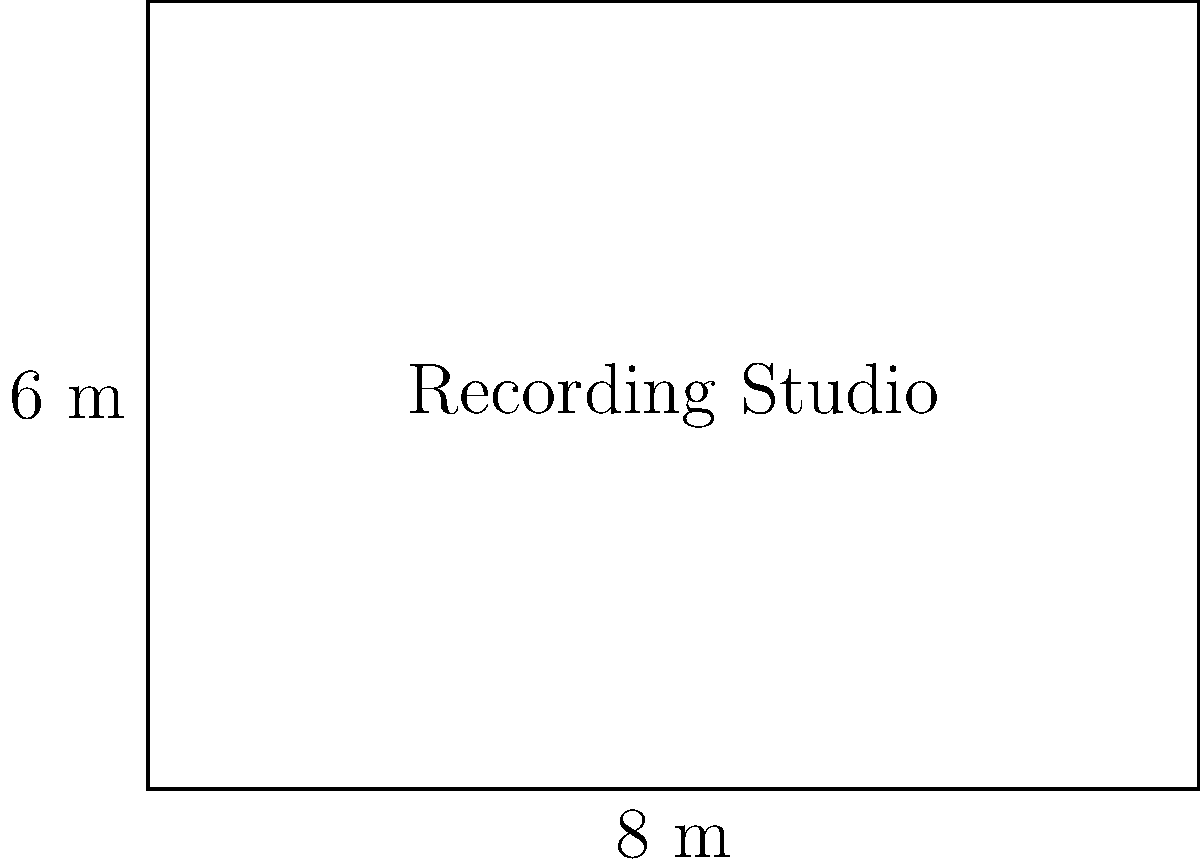You're designing a new rectangular recording studio for your classical music podcasts. The room measures 8 meters in length and 6 meters in width. What is the total floor area of your new recording studio in square meters? To find the area of a rectangular room, we need to multiply its length by its width.

1. Identify the given dimensions:
   - Length = 8 meters
   - Width = 6 meters

2. Apply the formula for the area of a rectangle:
   Area = Length × Width

3. Substitute the values into the formula:
   Area = 8 m × 6 m

4. Perform the multiplication:
   Area = 48 m²

Therefore, the total floor area of your new recording studio is 48 square meters.
Answer: 48 m² 